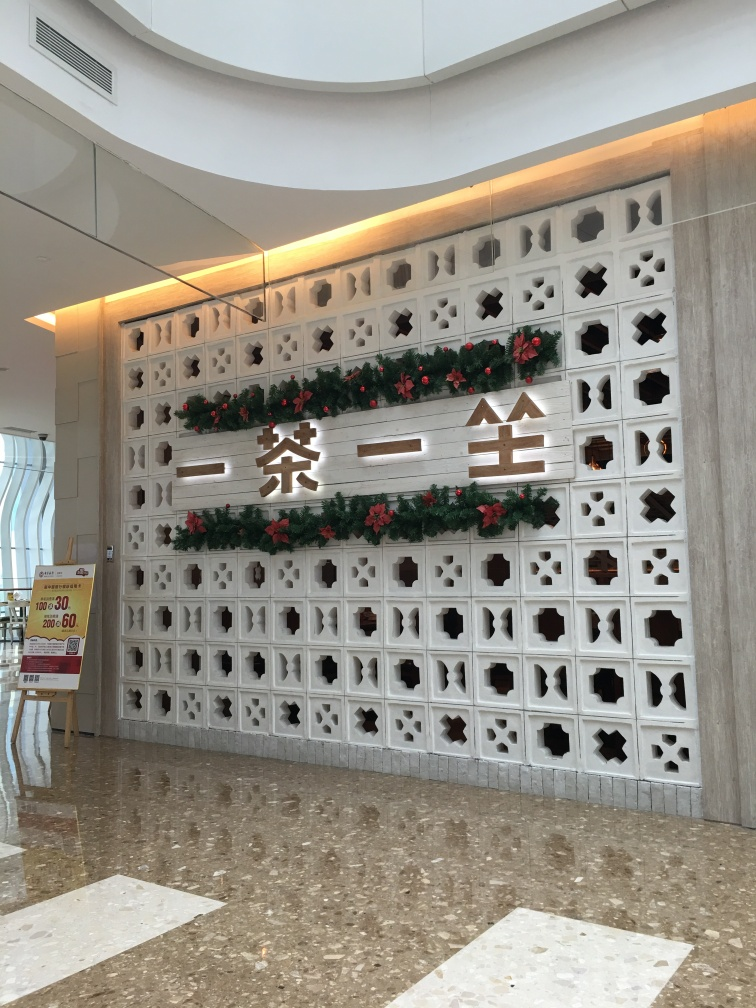Delve into the quality of the photograph and give a verdict based on your scrutiny. The photograph exhibits excellent resolution, as the details on the textured wall and the fonts are distinctly visible without any noticeable blur or distortion. The lighting is well-balanced, enhancing the visibility of details without creating harsh shadows or overexposed areas. The festive decorations, including the greenery and red ornaments, are vivid, suggesting good color fidelity in the capture. Overall, the photograph is of high quality, well-composed, and effectively showcases the architectural and decorative elements of the space. 